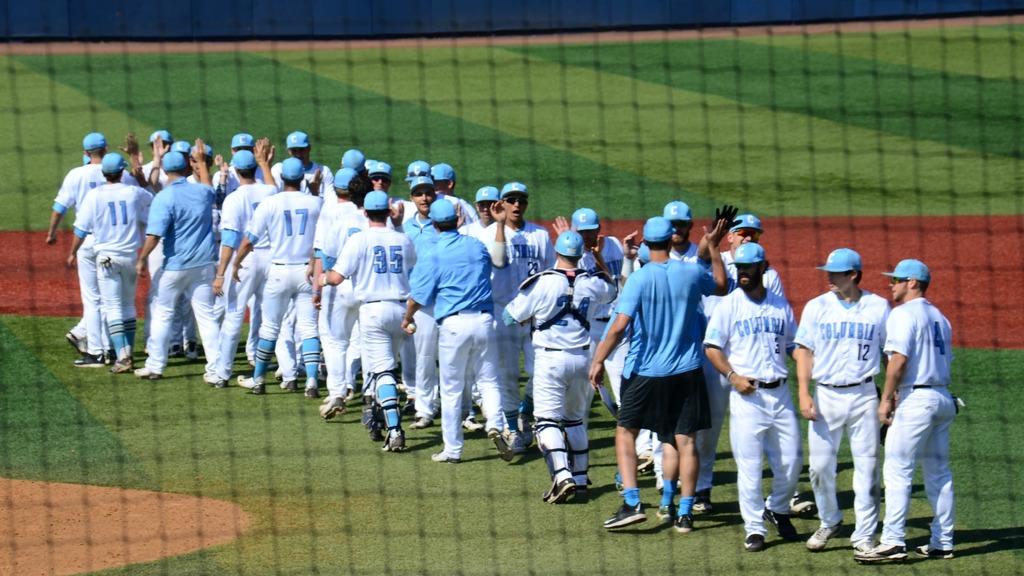What is the number of the player on the far right?
Your answer should be compact. 4. 